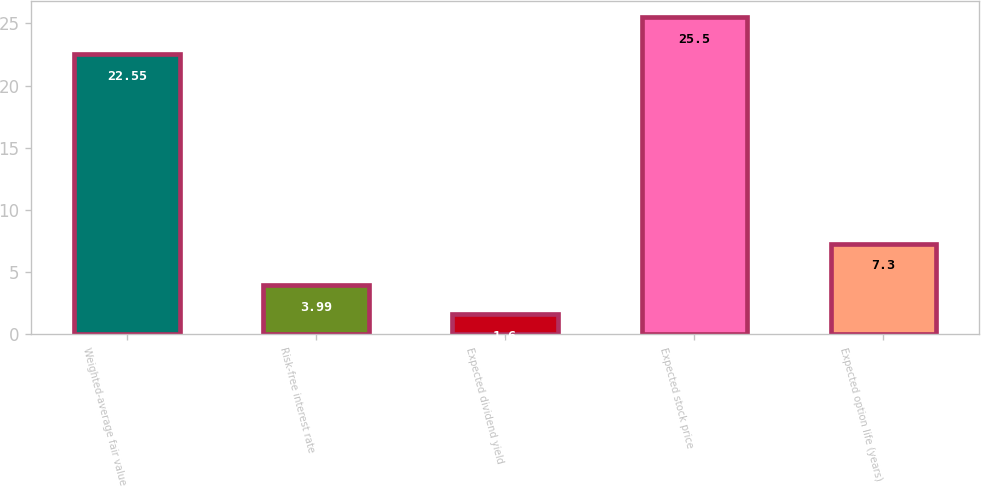Convert chart to OTSL. <chart><loc_0><loc_0><loc_500><loc_500><bar_chart><fcel>Weighted-average fair value<fcel>Risk-free interest rate<fcel>Expected dividend yield<fcel>Expected stock price<fcel>Expected option life (years)<nl><fcel>22.55<fcel>3.99<fcel>1.6<fcel>25.5<fcel>7.3<nl></chart> 